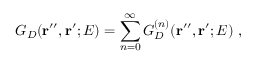Convert formula to latex. <formula><loc_0><loc_0><loc_500><loc_500>G _ { D } ( { r ^ { \prime \prime } } , { r ^ { \prime } } ; E ) = \sum _ { n = 0 } ^ { \infty } G _ { D } ^ { ( n ) } ( { r ^ { \prime \prime } } , { r ^ { \prime } } ; E ) \, ,</formula> 